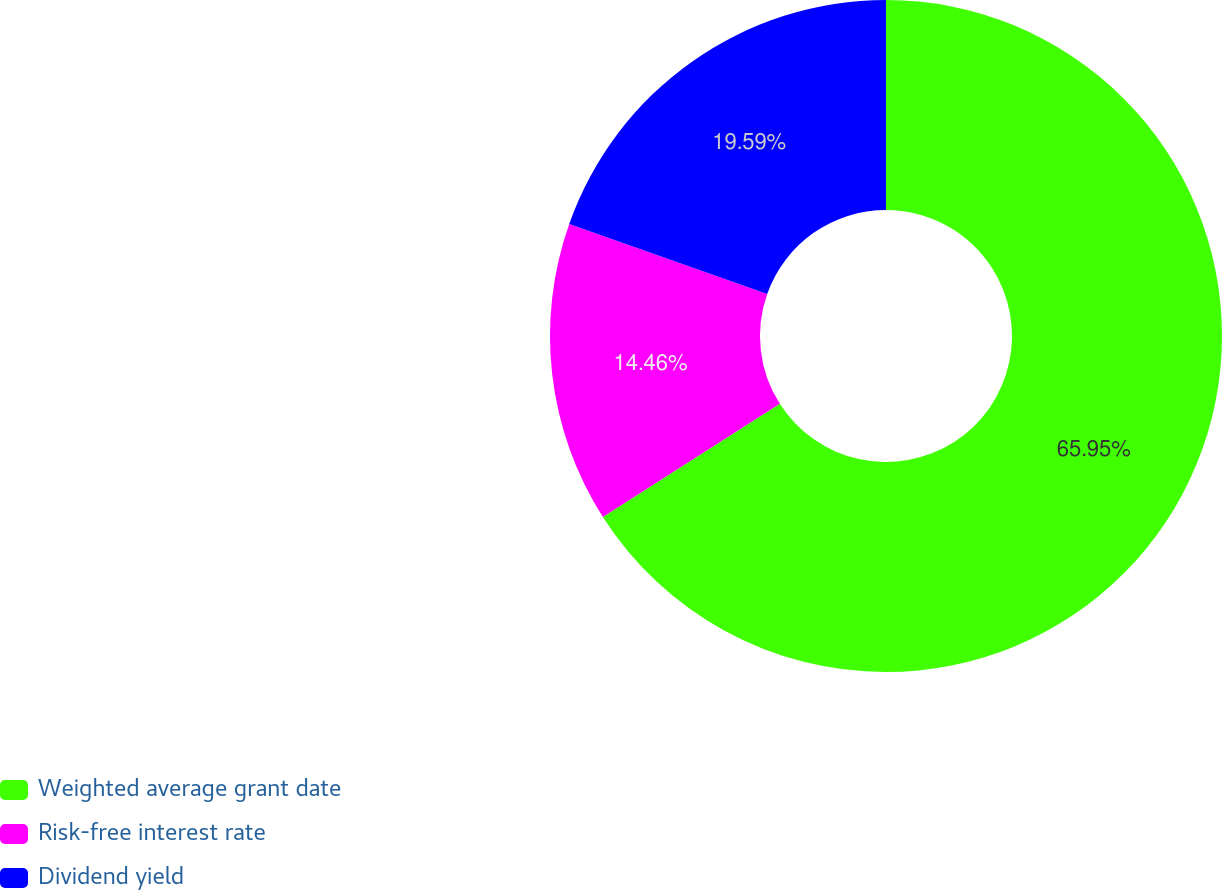Convert chart to OTSL. <chart><loc_0><loc_0><loc_500><loc_500><pie_chart><fcel>Weighted average grant date<fcel>Risk-free interest rate<fcel>Dividend yield<nl><fcel>65.95%<fcel>14.46%<fcel>19.59%<nl></chart> 